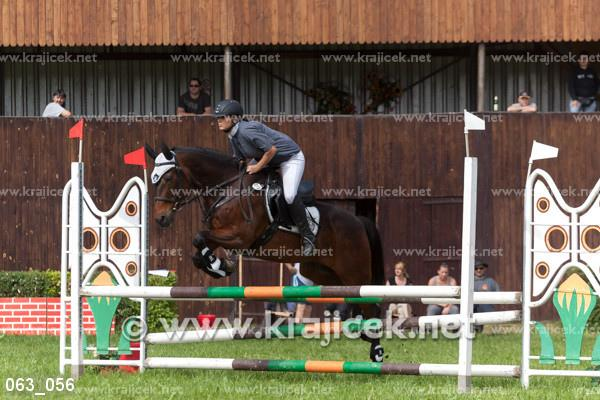Which bar is the horse meant to pass over? top 